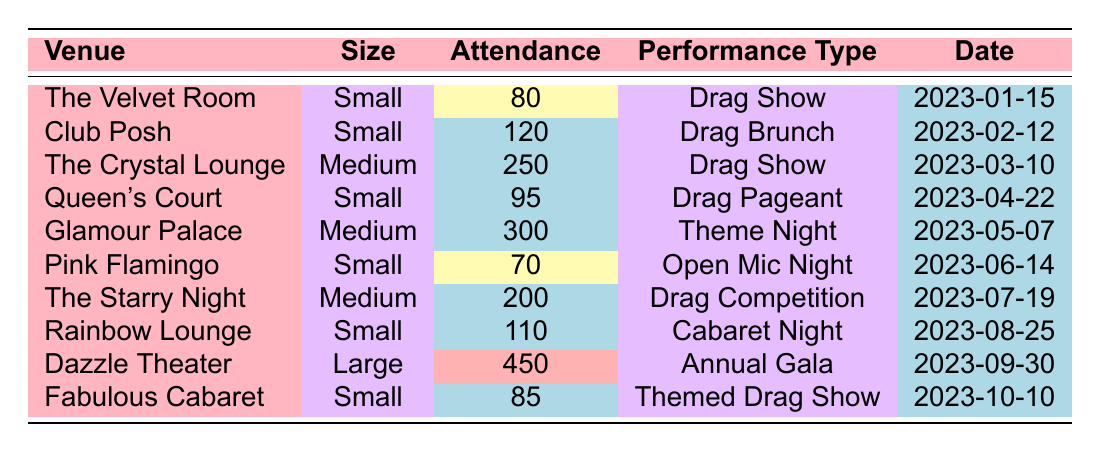What is the average attendance for small venues? To find the average attendance for small venues, we first identify the venues classified as small: The Velvet Room (80), Club Posh (120), Queen's Court (95), Pink Flamingo (70), Rainbow Lounge (110), and Fabulous Cabaret (85). We then sum these values: 80 + 120 + 95 + 70 + 110 + 85 = 560. There are 6 small venues, so we divide the total attendance by 6. Therefore, the average is 560 / 6 = 93.33.
Answer: 93.33 Which venue had the highest attendance? The highest attendance is found by comparing all average attendance values. The maximum value in the attendance column is 450 from Dazzle Theater.
Answer: Dazzle Theater Is the average attendance at medium venues higher than at small venues? Calculate the average attendance for medium venues (The Crystal Lounge: 250, Glamour Palace: 300, The Starry Night: 200), which totals 250 + 300 + 200 = 750. Dividing by 3 gives 750 / 3 = 250. The previous calculation found the average for small venues to be 93.33. Since 250 is greater than 93.33, the statement is true.
Answer: Yes How many small venues had attendance below the average attendance for small venues? From the previous average of 93.33 for small venues, we look for those with attendance below this value. The Velvet Room (80), Pink Flamingo (70), and Fabulous Cabaret (85) have attendance figures less than 93.33. There are 3 such venues.
Answer: 3 What is the total attendance for all performances in large venues? We check for any venues classified as large and find only Dazzle Theater with an attendance of 450. Since there are no other large venues, the total attendance is simply 450.
Answer: 450 Which small venue offered a Drag Show? Reviewing the data, there are two small venues that hosted Drag Shows: The Velvet Room and Fabulous Cabaret.
Answer: The Velvet Room and Fabulous Cabaret How does the attendance at the highest-attendance small venue compare to the lowest-attendance medium venue? The highest-attendance small venue is Club Posh at 120. The lowest-attendance medium venue is The Starry Night at 200. Comparing the two, 120 is less than 200.
Answer: 120 is less than 200 